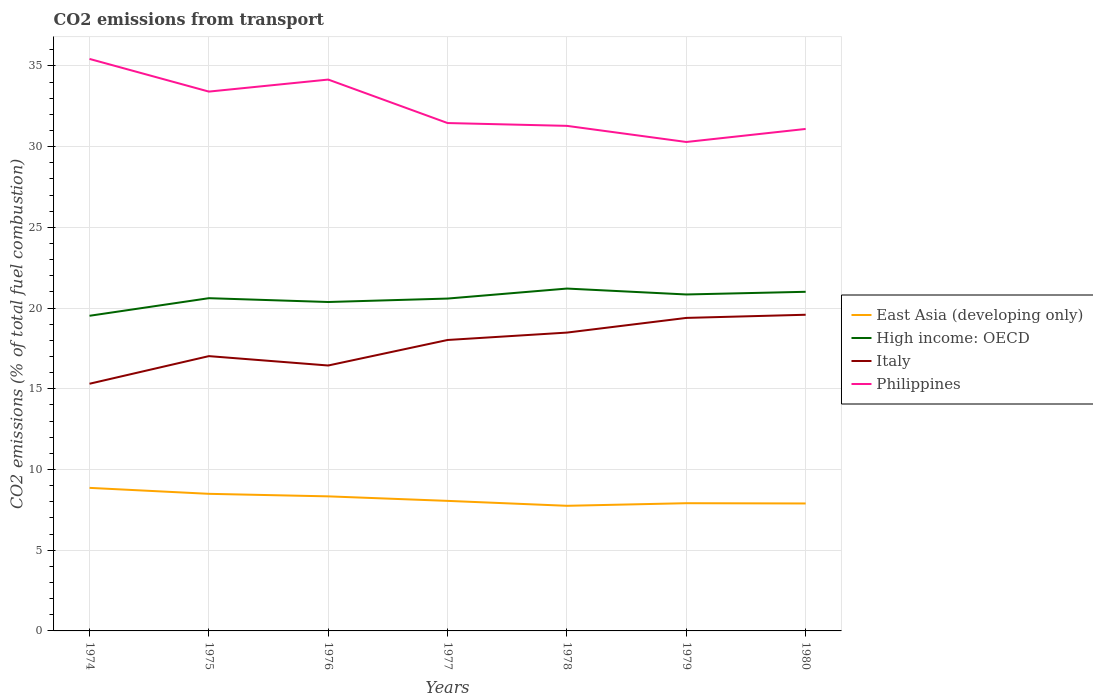How many different coloured lines are there?
Keep it short and to the point. 4. Is the number of lines equal to the number of legend labels?
Make the answer very short. Yes. Across all years, what is the maximum total CO2 emitted in East Asia (developing only)?
Provide a short and direct response. 7.75. In which year was the total CO2 emitted in Philippines maximum?
Offer a very short reply. 1979. What is the total total CO2 emitted in Italy in the graph?
Provide a short and direct response. -0.91. What is the difference between the highest and the second highest total CO2 emitted in High income: OECD?
Your response must be concise. 1.69. Is the total CO2 emitted in Philippines strictly greater than the total CO2 emitted in High income: OECD over the years?
Ensure brevity in your answer.  No. What is the difference between two consecutive major ticks on the Y-axis?
Keep it short and to the point. 5. Are the values on the major ticks of Y-axis written in scientific E-notation?
Make the answer very short. No. Does the graph contain any zero values?
Your answer should be very brief. No. Does the graph contain grids?
Provide a succinct answer. Yes. Where does the legend appear in the graph?
Offer a terse response. Center right. How many legend labels are there?
Keep it short and to the point. 4. How are the legend labels stacked?
Give a very brief answer. Vertical. What is the title of the graph?
Your answer should be very brief. CO2 emissions from transport. Does "Azerbaijan" appear as one of the legend labels in the graph?
Make the answer very short. No. What is the label or title of the Y-axis?
Give a very brief answer. CO2 emissions (% of total fuel combustion). What is the CO2 emissions (% of total fuel combustion) of East Asia (developing only) in 1974?
Offer a very short reply. 8.86. What is the CO2 emissions (% of total fuel combustion) of High income: OECD in 1974?
Offer a terse response. 19.52. What is the CO2 emissions (% of total fuel combustion) in Italy in 1974?
Offer a terse response. 15.31. What is the CO2 emissions (% of total fuel combustion) of Philippines in 1974?
Your answer should be compact. 35.44. What is the CO2 emissions (% of total fuel combustion) of East Asia (developing only) in 1975?
Your answer should be very brief. 8.49. What is the CO2 emissions (% of total fuel combustion) of High income: OECD in 1975?
Your response must be concise. 20.61. What is the CO2 emissions (% of total fuel combustion) in Italy in 1975?
Provide a succinct answer. 17.02. What is the CO2 emissions (% of total fuel combustion) in Philippines in 1975?
Offer a very short reply. 33.41. What is the CO2 emissions (% of total fuel combustion) of East Asia (developing only) in 1976?
Your answer should be compact. 8.34. What is the CO2 emissions (% of total fuel combustion) of High income: OECD in 1976?
Give a very brief answer. 20.38. What is the CO2 emissions (% of total fuel combustion) of Italy in 1976?
Offer a very short reply. 16.44. What is the CO2 emissions (% of total fuel combustion) of Philippines in 1976?
Make the answer very short. 34.16. What is the CO2 emissions (% of total fuel combustion) of East Asia (developing only) in 1977?
Offer a very short reply. 8.06. What is the CO2 emissions (% of total fuel combustion) in High income: OECD in 1977?
Provide a short and direct response. 20.59. What is the CO2 emissions (% of total fuel combustion) of Italy in 1977?
Provide a succinct answer. 18.03. What is the CO2 emissions (% of total fuel combustion) in Philippines in 1977?
Ensure brevity in your answer.  31.47. What is the CO2 emissions (% of total fuel combustion) of East Asia (developing only) in 1978?
Offer a terse response. 7.75. What is the CO2 emissions (% of total fuel combustion) in High income: OECD in 1978?
Provide a succinct answer. 21.21. What is the CO2 emissions (% of total fuel combustion) in Italy in 1978?
Make the answer very short. 18.48. What is the CO2 emissions (% of total fuel combustion) in Philippines in 1978?
Your answer should be very brief. 31.29. What is the CO2 emissions (% of total fuel combustion) in East Asia (developing only) in 1979?
Your response must be concise. 7.91. What is the CO2 emissions (% of total fuel combustion) in High income: OECD in 1979?
Your response must be concise. 20.85. What is the CO2 emissions (% of total fuel combustion) in Italy in 1979?
Offer a very short reply. 19.39. What is the CO2 emissions (% of total fuel combustion) in Philippines in 1979?
Your answer should be very brief. 30.29. What is the CO2 emissions (% of total fuel combustion) in East Asia (developing only) in 1980?
Make the answer very short. 7.9. What is the CO2 emissions (% of total fuel combustion) in High income: OECD in 1980?
Ensure brevity in your answer.  21.01. What is the CO2 emissions (% of total fuel combustion) of Italy in 1980?
Keep it short and to the point. 19.59. What is the CO2 emissions (% of total fuel combustion) of Philippines in 1980?
Provide a succinct answer. 31.1. Across all years, what is the maximum CO2 emissions (% of total fuel combustion) of East Asia (developing only)?
Make the answer very short. 8.86. Across all years, what is the maximum CO2 emissions (% of total fuel combustion) in High income: OECD?
Make the answer very short. 21.21. Across all years, what is the maximum CO2 emissions (% of total fuel combustion) of Italy?
Give a very brief answer. 19.59. Across all years, what is the maximum CO2 emissions (% of total fuel combustion) of Philippines?
Offer a terse response. 35.44. Across all years, what is the minimum CO2 emissions (% of total fuel combustion) of East Asia (developing only)?
Make the answer very short. 7.75. Across all years, what is the minimum CO2 emissions (% of total fuel combustion) of High income: OECD?
Your response must be concise. 19.52. Across all years, what is the minimum CO2 emissions (% of total fuel combustion) in Italy?
Give a very brief answer. 15.31. Across all years, what is the minimum CO2 emissions (% of total fuel combustion) of Philippines?
Ensure brevity in your answer.  30.29. What is the total CO2 emissions (% of total fuel combustion) in East Asia (developing only) in the graph?
Your response must be concise. 57.31. What is the total CO2 emissions (% of total fuel combustion) of High income: OECD in the graph?
Give a very brief answer. 144.17. What is the total CO2 emissions (% of total fuel combustion) in Italy in the graph?
Keep it short and to the point. 124.27. What is the total CO2 emissions (% of total fuel combustion) of Philippines in the graph?
Offer a terse response. 227.16. What is the difference between the CO2 emissions (% of total fuel combustion) of East Asia (developing only) in 1974 and that in 1975?
Make the answer very short. 0.37. What is the difference between the CO2 emissions (% of total fuel combustion) in High income: OECD in 1974 and that in 1975?
Make the answer very short. -1.09. What is the difference between the CO2 emissions (% of total fuel combustion) of Italy in 1974 and that in 1975?
Provide a short and direct response. -1.71. What is the difference between the CO2 emissions (% of total fuel combustion) in Philippines in 1974 and that in 1975?
Your response must be concise. 2.02. What is the difference between the CO2 emissions (% of total fuel combustion) of East Asia (developing only) in 1974 and that in 1976?
Provide a short and direct response. 0.53. What is the difference between the CO2 emissions (% of total fuel combustion) in High income: OECD in 1974 and that in 1976?
Your answer should be compact. -0.85. What is the difference between the CO2 emissions (% of total fuel combustion) in Italy in 1974 and that in 1976?
Offer a very short reply. -1.13. What is the difference between the CO2 emissions (% of total fuel combustion) in Philippines in 1974 and that in 1976?
Your response must be concise. 1.28. What is the difference between the CO2 emissions (% of total fuel combustion) in East Asia (developing only) in 1974 and that in 1977?
Offer a terse response. 0.81. What is the difference between the CO2 emissions (% of total fuel combustion) in High income: OECD in 1974 and that in 1977?
Offer a terse response. -1.07. What is the difference between the CO2 emissions (% of total fuel combustion) of Italy in 1974 and that in 1977?
Give a very brief answer. -2.71. What is the difference between the CO2 emissions (% of total fuel combustion) in Philippines in 1974 and that in 1977?
Keep it short and to the point. 3.97. What is the difference between the CO2 emissions (% of total fuel combustion) in East Asia (developing only) in 1974 and that in 1978?
Keep it short and to the point. 1.11. What is the difference between the CO2 emissions (% of total fuel combustion) in High income: OECD in 1974 and that in 1978?
Your response must be concise. -1.69. What is the difference between the CO2 emissions (% of total fuel combustion) of Italy in 1974 and that in 1978?
Your answer should be very brief. -3.17. What is the difference between the CO2 emissions (% of total fuel combustion) in Philippines in 1974 and that in 1978?
Provide a succinct answer. 4.15. What is the difference between the CO2 emissions (% of total fuel combustion) in East Asia (developing only) in 1974 and that in 1979?
Provide a short and direct response. 0.95. What is the difference between the CO2 emissions (% of total fuel combustion) in High income: OECD in 1974 and that in 1979?
Offer a terse response. -1.32. What is the difference between the CO2 emissions (% of total fuel combustion) in Italy in 1974 and that in 1979?
Give a very brief answer. -4.08. What is the difference between the CO2 emissions (% of total fuel combustion) in Philippines in 1974 and that in 1979?
Provide a short and direct response. 5.15. What is the difference between the CO2 emissions (% of total fuel combustion) of East Asia (developing only) in 1974 and that in 1980?
Make the answer very short. 0.97. What is the difference between the CO2 emissions (% of total fuel combustion) in High income: OECD in 1974 and that in 1980?
Offer a very short reply. -1.49. What is the difference between the CO2 emissions (% of total fuel combustion) of Italy in 1974 and that in 1980?
Your response must be concise. -4.27. What is the difference between the CO2 emissions (% of total fuel combustion) of Philippines in 1974 and that in 1980?
Make the answer very short. 4.34. What is the difference between the CO2 emissions (% of total fuel combustion) in East Asia (developing only) in 1975 and that in 1976?
Ensure brevity in your answer.  0.16. What is the difference between the CO2 emissions (% of total fuel combustion) in High income: OECD in 1975 and that in 1976?
Your answer should be very brief. 0.24. What is the difference between the CO2 emissions (% of total fuel combustion) in Italy in 1975 and that in 1976?
Give a very brief answer. 0.58. What is the difference between the CO2 emissions (% of total fuel combustion) of Philippines in 1975 and that in 1976?
Offer a terse response. -0.75. What is the difference between the CO2 emissions (% of total fuel combustion) in East Asia (developing only) in 1975 and that in 1977?
Your answer should be very brief. 0.44. What is the difference between the CO2 emissions (% of total fuel combustion) of High income: OECD in 1975 and that in 1977?
Ensure brevity in your answer.  0.02. What is the difference between the CO2 emissions (% of total fuel combustion) in Italy in 1975 and that in 1977?
Your answer should be very brief. -1. What is the difference between the CO2 emissions (% of total fuel combustion) of Philippines in 1975 and that in 1977?
Your response must be concise. 1.95. What is the difference between the CO2 emissions (% of total fuel combustion) in East Asia (developing only) in 1975 and that in 1978?
Your answer should be compact. 0.74. What is the difference between the CO2 emissions (% of total fuel combustion) of High income: OECD in 1975 and that in 1978?
Give a very brief answer. -0.6. What is the difference between the CO2 emissions (% of total fuel combustion) of Italy in 1975 and that in 1978?
Ensure brevity in your answer.  -1.46. What is the difference between the CO2 emissions (% of total fuel combustion) in Philippines in 1975 and that in 1978?
Offer a terse response. 2.12. What is the difference between the CO2 emissions (% of total fuel combustion) of East Asia (developing only) in 1975 and that in 1979?
Provide a succinct answer. 0.58. What is the difference between the CO2 emissions (% of total fuel combustion) in High income: OECD in 1975 and that in 1979?
Make the answer very short. -0.23. What is the difference between the CO2 emissions (% of total fuel combustion) of Italy in 1975 and that in 1979?
Your response must be concise. -2.37. What is the difference between the CO2 emissions (% of total fuel combustion) of Philippines in 1975 and that in 1979?
Your answer should be compact. 3.12. What is the difference between the CO2 emissions (% of total fuel combustion) in East Asia (developing only) in 1975 and that in 1980?
Your answer should be compact. 0.6. What is the difference between the CO2 emissions (% of total fuel combustion) in High income: OECD in 1975 and that in 1980?
Provide a succinct answer. -0.4. What is the difference between the CO2 emissions (% of total fuel combustion) of Italy in 1975 and that in 1980?
Your response must be concise. -2.56. What is the difference between the CO2 emissions (% of total fuel combustion) in Philippines in 1975 and that in 1980?
Your answer should be very brief. 2.31. What is the difference between the CO2 emissions (% of total fuel combustion) in East Asia (developing only) in 1976 and that in 1977?
Give a very brief answer. 0.28. What is the difference between the CO2 emissions (% of total fuel combustion) of High income: OECD in 1976 and that in 1977?
Provide a short and direct response. -0.21. What is the difference between the CO2 emissions (% of total fuel combustion) in Italy in 1976 and that in 1977?
Your response must be concise. -1.58. What is the difference between the CO2 emissions (% of total fuel combustion) in Philippines in 1976 and that in 1977?
Provide a succinct answer. 2.69. What is the difference between the CO2 emissions (% of total fuel combustion) in East Asia (developing only) in 1976 and that in 1978?
Keep it short and to the point. 0.58. What is the difference between the CO2 emissions (% of total fuel combustion) of High income: OECD in 1976 and that in 1978?
Your response must be concise. -0.83. What is the difference between the CO2 emissions (% of total fuel combustion) of Italy in 1976 and that in 1978?
Offer a very short reply. -2.04. What is the difference between the CO2 emissions (% of total fuel combustion) in Philippines in 1976 and that in 1978?
Give a very brief answer. 2.87. What is the difference between the CO2 emissions (% of total fuel combustion) in East Asia (developing only) in 1976 and that in 1979?
Your response must be concise. 0.42. What is the difference between the CO2 emissions (% of total fuel combustion) of High income: OECD in 1976 and that in 1979?
Ensure brevity in your answer.  -0.47. What is the difference between the CO2 emissions (% of total fuel combustion) of Italy in 1976 and that in 1979?
Provide a succinct answer. -2.95. What is the difference between the CO2 emissions (% of total fuel combustion) of Philippines in 1976 and that in 1979?
Make the answer very short. 3.87. What is the difference between the CO2 emissions (% of total fuel combustion) in East Asia (developing only) in 1976 and that in 1980?
Your answer should be very brief. 0.44. What is the difference between the CO2 emissions (% of total fuel combustion) in High income: OECD in 1976 and that in 1980?
Offer a very short reply. -0.63. What is the difference between the CO2 emissions (% of total fuel combustion) in Italy in 1976 and that in 1980?
Your answer should be very brief. -3.14. What is the difference between the CO2 emissions (% of total fuel combustion) in Philippines in 1976 and that in 1980?
Ensure brevity in your answer.  3.06. What is the difference between the CO2 emissions (% of total fuel combustion) in East Asia (developing only) in 1977 and that in 1978?
Offer a terse response. 0.31. What is the difference between the CO2 emissions (% of total fuel combustion) of High income: OECD in 1977 and that in 1978?
Your answer should be very brief. -0.62. What is the difference between the CO2 emissions (% of total fuel combustion) of Italy in 1977 and that in 1978?
Your answer should be very brief. -0.46. What is the difference between the CO2 emissions (% of total fuel combustion) in Philippines in 1977 and that in 1978?
Ensure brevity in your answer.  0.17. What is the difference between the CO2 emissions (% of total fuel combustion) in East Asia (developing only) in 1977 and that in 1979?
Ensure brevity in your answer.  0.14. What is the difference between the CO2 emissions (% of total fuel combustion) in High income: OECD in 1977 and that in 1979?
Make the answer very short. -0.25. What is the difference between the CO2 emissions (% of total fuel combustion) of Italy in 1977 and that in 1979?
Provide a short and direct response. -1.37. What is the difference between the CO2 emissions (% of total fuel combustion) in Philippines in 1977 and that in 1979?
Your response must be concise. 1.17. What is the difference between the CO2 emissions (% of total fuel combustion) in East Asia (developing only) in 1977 and that in 1980?
Ensure brevity in your answer.  0.16. What is the difference between the CO2 emissions (% of total fuel combustion) of High income: OECD in 1977 and that in 1980?
Offer a very short reply. -0.42. What is the difference between the CO2 emissions (% of total fuel combustion) in Italy in 1977 and that in 1980?
Your answer should be compact. -1.56. What is the difference between the CO2 emissions (% of total fuel combustion) in Philippines in 1977 and that in 1980?
Give a very brief answer. 0.37. What is the difference between the CO2 emissions (% of total fuel combustion) in East Asia (developing only) in 1978 and that in 1979?
Provide a short and direct response. -0.16. What is the difference between the CO2 emissions (% of total fuel combustion) of High income: OECD in 1978 and that in 1979?
Offer a very short reply. 0.37. What is the difference between the CO2 emissions (% of total fuel combustion) of Italy in 1978 and that in 1979?
Offer a terse response. -0.91. What is the difference between the CO2 emissions (% of total fuel combustion) of East Asia (developing only) in 1978 and that in 1980?
Your answer should be very brief. -0.14. What is the difference between the CO2 emissions (% of total fuel combustion) of High income: OECD in 1978 and that in 1980?
Offer a terse response. 0.2. What is the difference between the CO2 emissions (% of total fuel combustion) of Italy in 1978 and that in 1980?
Your response must be concise. -1.11. What is the difference between the CO2 emissions (% of total fuel combustion) in Philippines in 1978 and that in 1980?
Your answer should be compact. 0.19. What is the difference between the CO2 emissions (% of total fuel combustion) in East Asia (developing only) in 1979 and that in 1980?
Your response must be concise. 0.02. What is the difference between the CO2 emissions (% of total fuel combustion) in High income: OECD in 1979 and that in 1980?
Offer a very short reply. -0.17. What is the difference between the CO2 emissions (% of total fuel combustion) in Italy in 1979 and that in 1980?
Offer a very short reply. -0.2. What is the difference between the CO2 emissions (% of total fuel combustion) in Philippines in 1979 and that in 1980?
Make the answer very short. -0.81. What is the difference between the CO2 emissions (% of total fuel combustion) of East Asia (developing only) in 1974 and the CO2 emissions (% of total fuel combustion) of High income: OECD in 1975?
Your answer should be very brief. -11.75. What is the difference between the CO2 emissions (% of total fuel combustion) of East Asia (developing only) in 1974 and the CO2 emissions (% of total fuel combustion) of Italy in 1975?
Ensure brevity in your answer.  -8.16. What is the difference between the CO2 emissions (% of total fuel combustion) of East Asia (developing only) in 1974 and the CO2 emissions (% of total fuel combustion) of Philippines in 1975?
Give a very brief answer. -24.55. What is the difference between the CO2 emissions (% of total fuel combustion) of High income: OECD in 1974 and the CO2 emissions (% of total fuel combustion) of Italy in 1975?
Keep it short and to the point. 2.5. What is the difference between the CO2 emissions (% of total fuel combustion) in High income: OECD in 1974 and the CO2 emissions (% of total fuel combustion) in Philippines in 1975?
Give a very brief answer. -13.89. What is the difference between the CO2 emissions (% of total fuel combustion) of Italy in 1974 and the CO2 emissions (% of total fuel combustion) of Philippines in 1975?
Keep it short and to the point. -18.1. What is the difference between the CO2 emissions (% of total fuel combustion) of East Asia (developing only) in 1974 and the CO2 emissions (% of total fuel combustion) of High income: OECD in 1976?
Make the answer very short. -11.52. What is the difference between the CO2 emissions (% of total fuel combustion) of East Asia (developing only) in 1974 and the CO2 emissions (% of total fuel combustion) of Italy in 1976?
Your answer should be compact. -7.58. What is the difference between the CO2 emissions (% of total fuel combustion) of East Asia (developing only) in 1974 and the CO2 emissions (% of total fuel combustion) of Philippines in 1976?
Your answer should be very brief. -25.3. What is the difference between the CO2 emissions (% of total fuel combustion) of High income: OECD in 1974 and the CO2 emissions (% of total fuel combustion) of Italy in 1976?
Offer a very short reply. 3.08. What is the difference between the CO2 emissions (% of total fuel combustion) in High income: OECD in 1974 and the CO2 emissions (% of total fuel combustion) in Philippines in 1976?
Provide a short and direct response. -14.63. What is the difference between the CO2 emissions (% of total fuel combustion) in Italy in 1974 and the CO2 emissions (% of total fuel combustion) in Philippines in 1976?
Give a very brief answer. -18.84. What is the difference between the CO2 emissions (% of total fuel combustion) of East Asia (developing only) in 1974 and the CO2 emissions (% of total fuel combustion) of High income: OECD in 1977?
Ensure brevity in your answer.  -11.73. What is the difference between the CO2 emissions (% of total fuel combustion) in East Asia (developing only) in 1974 and the CO2 emissions (% of total fuel combustion) in Italy in 1977?
Give a very brief answer. -9.16. What is the difference between the CO2 emissions (% of total fuel combustion) of East Asia (developing only) in 1974 and the CO2 emissions (% of total fuel combustion) of Philippines in 1977?
Provide a short and direct response. -22.6. What is the difference between the CO2 emissions (% of total fuel combustion) in High income: OECD in 1974 and the CO2 emissions (% of total fuel combustion) in Italy in 1977?
Keep it short and to the point. 1.5. What is the difference between the CO2 emissions (% of total fuel combustion) of High income: OECD in 1974 and the CO2 emissions (% of total fuel combustion) of Philippines in 1977?
Your response must be concise. -11.94. What is the difference between the CO2 emissions (% of total fuel combustion) in Italy in 1974 and the CO2 emissions (% of total fuel combustion) in Philippines in 1977?
Offer a terse response. -16.15. What is the difference between the CO2 emissions (% of total fuel combustion) of East Asia (developing only) in 1974 and the CO2 emissions (% of total fuel combustion) of High income: OECD in 1978?
Make the answer very short. -12.35. What is the difference between the CO2 emissions (% of total fuel combustion) of East Asia (developing only) in 1974 and the CO2 emissions (% of total fuel combustion) of Italy in 1978?
Give a very brief answer. -9.62. What is the difference between the CO2 emissions (% of total fuel combustion) in East Asia (developing only) in 1974 and the CO2 emissions (% of total fuel combustion) in Philippines in 1978?
Make the answer very short. -22.43. What is the difference between the CO2 emissions (% of total fuel combustion) in High income: OECD in 1974 and the CO2 emissions (% of total fuel combustion) in Italy in 1978?
Provide a short and direct response. 1.04. What is the difference between the CO2 emissions (% of total fuel combustion) in High income: OECD in 1974 and the CO2 emissions (% of total fuel combustion) in Philippines in 1978?
Ensure brevity in your answer.  -11.77. What is the difference between the CO2 emissions (% of total fuel combustion) in Italy in 1974 and the CO2 emissions (% of total fuel combustion) in Philippines in 1978?
Your answer should be very brief. -15.98. What is the difference between the CO2 emissions (% of total fuel combustion) of East Asia (developing only) in 1974 and the CO2 emissions (% of total fuel combustion) of High income: OECD in 1979?
Provide a short and direct response. -11.98. What is the difference between the CO2 emissions (% of total fuel combustion) in East Asia (developing only) in 1974 and the CO2 emissions (% of total fuel combustion) in Italy in 1979?
Offer a terse response. -10.53. What is the difference between the CO2 emissions (% of total fuel combustion) in East Asia (developing only) in 1974 and the CO2 emissions (% of total fuel combustion) in Philippines in 1979?
Keep it short and to the point. -21.43. What is the difference between the CO2 emissions (% of total fuel combustion) in High income: OECD in 1974 and the CO2 emissions (% of total fuel combustion) in Italy in 1979?
Keep it short and to the point. 0.13. What is the difference between the CO2 emissions (% of total fuel combustion) of High income: OECD in 1974 and the CO2 emissions (% of total fuel combustion) of Philippines in 1979?
Make the answer very short. -10.77. What is the difference between the CO2 emissions (% of total fuel combustion) in Italy in 1974 and the CO2 emissions (% of total fuel combustion) in Philippines in 1979?
Give a very brief answer. -14.98. What is the difference between the CO2 emissions (% of total fuel combustion) in East Asia (developing only) in 1974 and the CO2 emissions (% of total fuel combustion) in High income: OECD in 1980?
Provide a short and direct response. -12.15. What is the difference between the CO2 emissions (% of total fuel combustion) of East Asia (developing only) in 1974 and the CO2 emissions (% of total fuel combustion) of Italy in 1980?
Your response must be concise. -10.73. What is the difference between the CO2 emissions (% of total fuel combustion) in East Asia (developing only) in 1974 and the CO2 emissions (% of total fuel combustion) in Philippines in 1980?
Make the answer very short. -22.24. What is the difference between the CO2 emissions (% of total fuel combustion) in High income: OECD in 1974 and the CO2 emissions (% of total fuel combustion) in Italy in 1980?
Provide a short and direct response. -0.06. What is the difference between the CO2 emissions (% of total fuel combustion) of High income: OECD in 1974 and the CO2 emissions (% of total fuel combustion) of Philippines in 1980?
Offer a very short reply. -11.58. What is the difference between the CO2 emissions (% of total fuel combustion) of Italy in 1974 and the CO2 emissions (% of total fuel combustion) of Philippines in 1980?
Make the answer very short. -15.79. What is the difference between the CO2 emissions (% of total fuel combustion) of East Asia (developing only) in 1975 and the CO2 emissions (% of total fuel combustion) of High income: OECD in 1976?
Offer a very short reply. -11.88. What is the difference between the CO2 emissions (% of total fuel combustion) of East Asia (developing only) in 1975 and the CO2 emissions (% of total fuel combustion) of Italy in 1976?
Your response must be concise. -7.95. What is the difference between the CO2 emissions (% of total fuel combustion) of East Asia (developing only) in 1975 and the CO2 emissions (% of total fuel combustion) of Philippines in 1976?
Give a very brief answer. -25.67. What is the difference between the CO2 emissions (% of total fuel combustion) in High income: OECD in 1975 and the CO2 emissions (% of total fuel combustion) in Italy in 1976?
Keep it short and to the point. 4.17. What is the difference between the CO2 emissions (% of total fuel combustion) in High income: OECD in 1975 and the CO2 emissions (% of total fuel combustion) in Philippines in 1976?
Give a very brief answer. -13.54. What is the difference between the CO2 emissions (% of total fuel combustion) in Italy in 1975 and the CO2 emissions (% of total fuel combustion) in Philippines in 1976?
Provide a short and direct response. -17.13. What is the difference between the CO2 emissions (% of total fuel combustion) in East Asia (developing only) in 1975 and the CO2 emissions (% of total fuel combustion) in High income: OECD in 1977?
Offer a terse response. -12.1. What is the difference between the CO2 emissions (% of total fuel combustion) of East Asia (developing only) in 1975 and the CO2 emissions (% of total fuel combustion) of Italy in 1977?
Provide a succinct answer. -9.53. What is the difference between the CO2 emissions (% of total fuel combustion) in East Asia (developing only) in 1975 and the CO2 emissions (% of total fuel combustion) in Philippines in 1977?
Your response must be concise. -22.97. What is the difference between the CO2 emissions (% of total fuel combustion) in High income: OECD in 1975 and the CO2 emissions (% of total fuel combustion) in Italy in 1977?
Provide a succinct answer. 2.59. What is the difference between the CO2 emissions (% of total fuel combustion) of High income: OECD in 1975 and the CO2 emissions (% of total fuel combustion) of Philippines in 1977?
Provide a succinct answer. -10.85. What is the difference between the CO2 emissions (% of total fuel combustion) in Italy in 1975 and the CO2 emissions (% of total fuel combustion) in Philippines in 1977?
Offer a terse response. -14.44. What is the difference between the CO2 emissions (% of total fuel combustion) in East Asia (developing only) in 1975 and the CO2 emissions (% of total fuel combustion) in High income: OECD in 1978?
Keep it short and to the point. -12.72. What is the difference between the CO2 emissions (% of total fuel combustion) of East Asia (developing only) in 1975 and the CO2 emissions (% of total fuel combustion) of Italy in 1978?
Offer a terse response. -9.99. What is the difference between the CO2 emissions (% of total fuel combustion) of East Asia (developing only) in 1975 and the CO2 emissions (% of total fuel combustion) of Philippines in 1978?
Provide a succinct answer. -22.8. What is the difference between the CO2 emissions (% of total fuel combustion) in High income: OECD in 1975 and the CO2 emissions (% of total fuel combustion) in Italy in 1978?
Provide a succinct answer. 2.13. What is the difference between the CO2 emissions (% of total fuel combustion) in High income: OECD in 1975 and the CO2 emissions (% of total fuel combustion) in Philippines in 1978?
Ensure brevity in your answer.  -10.68. What is the difference between the CO2 emissions (% of total fuel combustion) in Italy in 1975 and the CO2 emissions (% of total fuel combustion) in Philippines in 1978?
Keep it short and to the point. -14.27. What is the difference between the CO2 emissions (% of total fuel combustion) of East Asia (developing only) in 1975 and the CO2 emissions (% of total fuel combustion) of High income: OECD in 1979?
Give a very brief answer. -12.35. What is the difference between the CO2 emissions (% of total fuel combustion) of East Asia (developing only) in 1975 and the CO2 emissions (% of total fuel combustion) of Italy in 1979?
Your response must be concise. -10.9. What is the difference between the CO2 emissions (% of total fuel combustion) of East Asia (developing only) in 1975 and the CO2 emissions (% of total fuel combustion) of Philippines in 1979?
Give a very brief answer. -21.8. What is the difference between the CO2 emissions (% of total fuel combustion) in High income: OECD in 1975 and the CO2 emissions (% of total fuel combustion) in Italy in 1979?
Provide a succinct answer. 1.22. What is the difference between the CO2 emissions (% of total fuel combustion) in High income: OECD in 1975 and the CO2 emissions (% of total fuel combustion) in Philippines in 1979?
Keep it short and to the point. -9.68. What is the difference between the CO2 emissions (% of total fuel combustion) in Italy in 1975 and the CO2 emissions (% of total fuel combustion) in Philippines in 1979?
Provide a succinct answer. -13.27. What is the difference between the CO2 emissions (% of total fuel combustion) in East Asia (developing only) in 1975 and the CO2 emissions (% of total fuel combustion) in High income: OECD in 1980?
Your response must be concise. -12.52. What is the difference between the CO2 emissions (% of total fuel combustion) in East Asia (developing only) in 1975 and the CO2 emissions (% of total fuel combustion) in Italy in 1980?
Offer a very short reply. -11.1. What is the difference between the CO2 emissions (% of total fuel combustion) in East Asia (developing only) in 1975 and the CO2 emissions (% of total fuel combustion) in Philippines in 1980?
Your answer should be compact. -22.61. What is the difference between the CO2 emissions (% of total fuel combustion) of High income: OECD in 1975 and the CO2 emissions (% of total fuel combustion) of Italy in 1980?
Provide a short and direct response. 1.03. What is the difference between the CO2 emissions (% of total fuel combustion) in High income: OECD in 1975 and the CO2 emissions (% of total fuel combustion) in Philippines in 1980?
Your answer should be compact. -10.49. What is the difference between the CO2 emissions (% of total fuel combustion) of Italy in 1975 and the CO2 emissions (% of total fuel combustion) of Philippines in 1980?
Your answer should be very brief. -14.07. What is the difference between the CO2 emissions (% of total fuel combustion) of East Asia (developing only) in 1976 and the CO2 emissions (% of total fuel combustion) of High income: OECD in 1977?
Ensure brevity in your answer.  -12.25. What is the difference between the CO2 emissions (% of total fuel combustion) in East Asia (developing only) in 1976 and the CO2 emissions (% of total fuel combustion) in Italy in 1977?
Provide a succinct answer. -9.69. What is the difference between the CO2 emissions (% of total fuel combustion) in East Asia (developing only) in 1976 and the CO2 emissions (% of total fuel combustion) in Philippines in 1977?
Ensure brevity in your answer.  -23.13. What is the difference between the CO2 emissions (% of total fuel combustion) of High income: OECD in 1976 and the CO2 emissions (% of total fuel combustion) of Italy in 1977?
Provide a short and direct response. 2.35. What is the difference between the CO2 emissions (% of total fuel combustion) in High income: OECD in 1976 and the CO2 emissions (% of total fuel combustion) in Philippines in 1977?
Offer a terse response. -11.09. What is the difference between the CO2 emissions (% of total fuel combustion) in Italy in 1976 and the CO2 emissions (% of total fuel combustion) in Philippines in 1977?
Give a very brief answer. -15.02. What is the difference between the CO2 emissions (% of total fuel combustion) in East Asia (developing only) in 1976 and the CO2 emissions (% of total fuel combustion) in High income: OECD in 1978?
Ensure brevity in your answer.  -12.87. What is the difference between the CO2 emissions (% of total fuel combustion) of East Asia (developing only) in 1976 and the CO2 emissions (% of total fuel combustion) of Italy in 1978?
Keep it short and to the point. -10.15. What is the difference between the CO2 emissions (% of total fuel combustion) of East Asia (developing only) in 1976 and the CO2 emissions (% of total fuel combustion) of Philippines in 1978?
Give a very brief answer. -22.95. What is the difference between the CO2 emissions (% of total fuel combustion) in High income: OECD in 1976 and the CO2 emissions (% of total fuel combustion) in Italy in 1978?
Make the answer very short. 1.9. What is the difference between the CO2 emissions (% of total fuel combustion) in High income: OECD in 1976 and the CO2 emissions (% of total fuel combustion) in Philippines in 1978?
Your answer should be compact. -10.91. What is the difference between the CO2 emissions (% of total fuel combustion) in Italy in 1976 and the CO2 emissions (% of total fuel combustion) in Philippines in 1978?
Ensure brevity in your answer.  -14.85. What is the difference between the CO2 emissions (% of total fuel combustion) in East Asia (developing only) in 1976 and the CO2 emissions (% of total fuel combustion) in High income: OECD in 1979?
Keep it short and to the point. -12.51. What is the difference between the CO2 emissions (% of total fuel combustion) of East Asia (developing only) in 1976 and the CO2 emissions (% of total fuel combustion) of Italy in 1979?
Give a very brief answer. -11.06. What is the difference between the CO2 emissions (% of total fuel combustion) of East Asia (developing only) in 1976 and the CO2 emissions (% of total fuel combustion) of Philippines in 1979?
Provide a succinct answer. -21.96. What is the difference between the CO2 emissions (% of total fuel combustion) of High income: OECD in 1976 and the CO2 emissions (% of total fuel combustion) of Italy in 1979?
Offer a very short reply. 0.99. What is the difference between the CO2 emissions (% of total fuel combustion) in High income: OECD in 1976 and the CO2 emissions (% of total fuel combustion) in Philippines in 1979?
Your response must be concise. -9.91. What is the difference between the CO2 emissions (% of total fuel combustion) of Italy in 1976 and the CO2 emissions (% of total fuel combustion) of Philippines in 1979?
Your answer should be compact. -13.85. What is the difference between the CO2 emissions (% of total fuel combustion) of East Asia (developing only) in 1976 and the CO2 emissions (% of total fuel combustion) of High income: OECD in 1980?
Make the answer very short. -12.67. What is the difference between the CO2 emissions (% of total fuel combustion) in East Asia (developing only) in 1976 and the CO2 emissions (% of total fuel combustion) in Italy in 1980?
Provide a short and direct response. -11.25. What is the difference between the CO2 emissions (% of total fuel combustion) of East Asia (developing only) in 1976 and the CO2 emissions (% of total fuel combustion) of Philippines in 1980?
Your answer should be compact. -22.76. What is the difference between the CO2 emissions (% of total fuel combustion) of High income: OECD in 1976 and the CO2 emissions (% of total fuel combustion) of Italy in 1980?
Provide a short and direct response. 0.79. What is the difference between the CO2 emissions (% of total fuel combustion) in High income: OECD in 1976 and the CO2 emissions (% of total fuel combustion) in Philippines in 1980?
Keep it short and to the point. -10.72. What is the difference between the CO2 emissions (% of total fuel combustion) of Italy in 1976 and the CO2 emissions (% of total fuel combustion) of Philippines in 1980?
Give a very brief answer. -14.66. What is the difference between the CO2 emissions (% of total fuel combustion) in East Asia (developing only) in 1977 and the CO2 emissions (% of total fuel combustion) in High income: OECD in 1978?
Provide a short and direct response. -13.15. What is the difference between the CO2 emissions (% of total fuel combustion) in East Asia (developing only) in 1977 and the CO2 emissions (% of total fuel combustion) in Italy in 1978?
Your answer should be compact. -10.43. What is the difference between the CO2 emissions (% of total fuel combustion) in East Asia (developing only) in 1977 and the CO2 emissions (% of total fuel combustion) in Philippines in 1978?
Make the answer very short. -23.23. What is the difference between the CO2 emissions (% of total fuel combustion) of High income: OECD in 1977 and the CO2 emissions (% of total fuel combustion) of Italy in 1978?
Provide a succinct answer. 2.11. What is the difference between the CO2 emissions (% of total fuel combustion) of High income: OECD in 1977 and the CO2 emissions (% of total fuel combustion) of Philippines in 1978?
Keep it short and to the point. -10.7. What is the difference between the CO2 emissions (% of total fuel combustion) in Italy in 1977 and the CO2 emissions (% of total fuel combustion) in Philippines in 1978?
Provide a short and direct response. -13.27. What is the difference between the CO2 emissions (% of total fuel combustion) of East Asia (developing only) in 1977 and the CO2 emissions (% of total fuel combustion) of High income: OECD in 1979?
Offer a very short reply. -12.79. What is the difference between the CO2 emissions (% of total fuel combustion) of East Asia (developing only) in 1977 and the CO2 emissions (% of total fuel combustion) of Italy in 1979?
Your answer should be very brief. -11.34. What is the difference between the CO2 emissions (% of total fuel combustion) in East Asia (developing only) in 1977 and the CO2 emissions (% of total fuel combustion) in Philippines in 1979?
Provide a succinct answer. -22.23. What is the difference between the CO2 emissions (% of total fuel combustion) in High income: OECD in 1977 and the CO2 emissions (% of total fuel combustion) in Italy in 1979?
Ensure brevity in your answer.  1.2. What is the difference between the CO2 emissions (% of total fuel combustion) in High income: OECD in 1977 and the CO2 emissions (% of total fuel combustion) in Philippines in 1979?
Make the answer very short. -9.7. What is the difference between the CO2 emissions (% of total fuel combustion) in Italy in 1977 and the CO2 emissions (% of total fuel combustion) in Philippines in 1979?
Keep it short and to the point. -12.27. What is the difference between the CO2 emissions (% of total fuel combustion) of East Asia (developing only) in 1977 and the CO2 emissions (% of total fuel combustion) of High income: OECD in 1980?
Give a very brief answer. -12.95. What is the difference between the CO2 emissions (% of total fuel combustion) in East Asia (developing only) in 1977 and the CO2 emissions (% of total fuel combustion) in Italy in 1980?
Give a very brief answer. -11.53. What is the difference between the CO2 emissions (% of total fuel combustion) in East Asia (developing only) in 1977 and the CO2 emissions (% of total fuel combustion) in Philippines in 1980?
Provide a succinct answer. -23.04. What is the difference between the CO2 emissions (% of total fuel combustion) in High income: OECD in 1977 and the CO2 emissions (% of total fuel combustion) in Philippines in 1980?
Make the answer very short. -10.51. What is the difference between the CO2 emissions (% of total fuel combustion) of Italy in 1977 and the CO2 emissions (% of total fuel combustion) of Philippines in 1980?
Provide a short and direct response. -13.07. What is the difference between the CO2 emissions (% of total fuel combustion) in East Asia (developing only) in 1978 and the CO2 emissions (% of total fuel combustion) in High income: OECD in 1979?
Make the answer very short. -13.09. What is the difference between the CO2 emissions (% of total fuel combustion) of East Asia (developing only) in 1978 and the CO2 emissions (% of total fuel combustion) of Italy in 1979?
Offer a terse response. -11.64. What is the difference between the CO2 emissions (% of total fuel combustion) in East Asia (developing only) in 1978 and the CO2 emissions (% of total fuel combustion) in Philippines in 1979?
Provide a succinct answer. -22.54. What is the difference between the CO2 emissions (% of total fuel combustion) in High income: OECD in 1978 and the CO2 emissions (% of total fuel combustion) in Italy in 1979?
Provide a succinct answer. 1.82. What is the difference between the CO2 emissions (% of total fuel combustion) of High income: OECD in 1978 and the CO2 emissions (% of total fuel combustion) of Philippines in 1979?
Ensure brevity in your answer.  -9.08. What is the difference between the CO2 emissions (% of total fuel combustion) of Italy in 1978 and the CO2 emissions (% of total fuel combustion) of Philippines in 1979?
Provide a succinct answer. -11.81. What is the difference between the CO2 emissions (% of total fuel combustion) in East Asia (developing only) in 1978 and the CO2 emissions (% of total fuel combustion) in High income: OECD in 1980?
Your response must be concise. -13.26. What is the difference between the CO2 emissions (% of total fuel combustion) in East Asia (developing only) in 1978 and the CO2 emissions (% of total fuel combustion) in Italy in 1980?
Offer a very short reply. -11.84. What is the difference between the CO2 emissions (% of total fuel combustion) in East Asia (developing only) in 1978 and the CO2 emissions (% of total fuel combustion) in Philippines in 1980?
Offer a very short reply. -23.35. What is the difference between the CO2 emissions (% of total fuel combustion) in High income: OECD in 1978 and the CO2 emissions (% of total fuel combustion) in Italy in 1980?
Give a very brief answer. 1.62. What is the difference between the CO2 emissions (% of total fuel combustion) in High income: OECD in 1978 and the CO2 emissions (% of total fuel combustion) in Philippines in 1980?
Your answer should be very brief. -9.89. What is the difference between the CO2 emissions (% of total fuel combustion) in Italy in 1978 and the CO2 emissions (% of total fuel combustion) in Philippines in 1980?
Provide a succinct answer. -12.62. What is the difference between the CO2 emissions (% of total fuel combustion) in East Asia (developing only) in 1979 and the CO2 emissions (% of total fuel combustion) in High income: OECD in 1980?
Make the answer very short. -13.1. What is the difference between the CO2 emissions (% of total fuel combustion) of East Asia (developing only) in 1979 and the CO2 emissions (% of total fuel combustion) of Italy in 1980?
Offer a very short reply. -11.68. What is the difference between the CO2 emissions (% of total fuel combustion) of East Asia (developing only) in 1979 and the CO2 emissions (% of total fuel combustion) of Philippines in 1980?
Your response must be concise. -23.19. What is the difference between the CO2 emissions (% of total fuel combustion) of High income: OECD in 1979 and the CO2 emissions (% of total fuel combustion) of Italy in 1980?
Provide a succinct answer. 1.26. What is the difference between the CO2 emissions (% of total fuel combustion) of High income: OECD in 1979 and the CO2 emissions (% of total fuel combustion) of Philippines in 1980?
Ensure brevity in your answer.  -10.25. What is the difference between the CO2 emissions (% of total fuel combustion) of Italy in 1979 and the CO2 emissions (% of total fuel combustion) of Philippines in 1980?
Your response must be concise. -11.71. What is the average CO2 emissions (% of total fuel combustion) in East Asia (developing only) per year?
Your answer should be very brief. 8.19. What is the average CO2 emissions (% of total fuel combustion) of High income: OECD per year?
Your answer should be very brief. 20.6. What is the average CO2 emissions (% of total fuel combustion) in Italy per year?
Provide a short and direct response. 17.75. What is the average CO2 emissions (% of total fuel combustion) of Philippines per year?
Make the answer very short. 32.45. In the year 1974, what is the difference between the CO2 emissions (% of total fuel combustion) of East Asia (developing only) and CO2 emissions (% of total fuel combustion) of High income: OECD?
Make the answer very short. -10.66. In the year 1974, what is the difference between the CO2 emissions (% of total fuel combustion) in East Asia (developing only) and CO2 emissions (% of total fuel combustion) in Italy?
Keep it short and to the point. -6.45. In the year 1974, what is the difference between the CO2 emissions (% of total fuel combustion) in East Asia (developing only) and CO2 emissions (% of total fuel combustion) in Philippines?
Your answer should be very brief. -26.58. In the year 1974, what is the difference between the CO2 emissions (% of total fuel combustion) of High income: OECD and CO2 emissions (% of total fuel combustion) of Italy?
Your response must be concise. 4.21. In the year 1974, what is the difference between the CO2 emissions (% of total fuel combustion) of High income: OECD and CO2 emissions (% of total fuel combustion) of Philippines?
Give a very brief answer. -15.91. In the year 1974, what is the difference between the CO2 emissions (% of total fuel combustion) in Italy and CO2 emissions (% of total fuel combustion) in Philippines?
Your answer should be compact. -20.12. In the year 1975, what is the difference between the CO2 emissions (% of total fuel combustion) in East Asia (developing only) and CO2 emissions (% of total fuel combustion) in High income: OECD?
Provide a succinct answer. -12.12. In the year 1975, what is the difference between the CO2 emissions (% of total fuel combustion) of East Asia (developing only) and CO2 emissions (% of total fuel combustion) of Italy?
Make the answer very short. -8.53. In the year 1975, what is the difference between the CO2 emissions (% of total fuel combustion) in East Asia (developing only) and CO2 emissions (% of total fuel combustion) in Philippines?
Provide a short and direct response. -24.92. In the year 1975, what is the difference between the CO2 emissions (% of total fuel combustion) in High income: OECD and CO2 emissions (% of total fuel combustion) in Italy?
Your answer should be compact. 3.59. In the year 1975, what is the difference between the CO2 emissions (% of total fuel combustion) of High income: OECD and CO2 emissions (% of total fuel combustion) of Philippines?
Ensure brevity in your answer.  -12.8. In the year 1975, what is the difference between the CO2 emissions (% of total fuel combustion) in Italy and CO2 emissions (% of total fuel combustion) in Philippines?
Provide a short and direct response. -16.39. In the year 1976, what is the difference between the CO2 emissions (% of total fuel combustion) in East Asia (developing only) and CO2 emissions (% of total fuel combustion) in High income: OECD?
Keep it short and to the point. -12.04. In the year 1976, what is the difference between the CO2 emissions (% of total fuel combustion) of East Asia (developing only) and CO2 emissions (% of total fuel combustion) of Italy?
Offer a very short reply. -8.11. In the year 1976, what is the difference between the CO2 emissions (% of total fuel combustion) of East Asia (developing only) and CO2 emissions (% of total fuel combustion) of Philippines?
Provide a short and direct response. -25.82. In the year 1976, what is the difference between the CO2 emissions (% of total fuel combustion) of High income: OECD and CO2 emissions (% of total fuel combustion) of Italy?
Provide a short and direct response. 3.93. In the year 1976, what is the difference between the CO2 emissions (% of total fuel combustion) in High income: OECD and CO2 emissions (% of total fuel combustion) in Philippines?
Offer a very short reply. -13.78. In the year 1976, what is the difference between the CO2 emissions (% of total fuel combustion) of Italy and CO2 emissions (% of total fuel combustion) of Philippines?
Your answer should be very brief. -17.71. In the year 1977, what is the difference between the CO2 emissions (% of total fuel combustion) of East Asia (developing only) and CO2 emissions (% of total fuel combustion) of High income: OECD?
Provide a succinct answer. -12.53. In the year 1977, what is the difference between the CO2 emissions (% of total fuel combustion) in East Asia (developing only) and CO2 emissions (% of total fuel combustion) in Italy?
Your answer should be compact. -9.97. In the year 1977, what is the difference between the CO2 emissions (% of total fuel combustion) in East Asia (developing only) and CO2 emissions (% of total fuel combustion) in Philippines?
Your answer should be very brief. -23.41. In the year 1977, what is the difference between the CO2 emissions (% of total fuel combustion) of High income: OECD and CO2 emissions (% of total fuel combustion) of Italy?
Your response must be concise. 2.57. In the year 1977, what is the difference between the CO2 emissions (% of total fuel combustion) of High income: OECD and CO2 emissions (% of total fuel combustion) of Philippines?
Provide a succinct answer. -10.87. In the year 1977, what is the difference between the CO2 emissions (% of total fuel combustion) of Italy and CO2 emissions (% of total fuel combustion) of Philippines?
Your response must be concise. -13.44. In the year 1978, what is the difference between the CO2 emissions (% of total fuel combustion) in East Asia (developing only) and CO2 emissions (% of total fuel combustion) in High income: OECD?
Provide a short and direct response. -13.46. In the year 1978, what is the difference between the CO2 emissions (% of total fuel combustion) of East Asia (developing only) and CO2 emissions (% of total fuel combustion) of Italy?
Provide a succinct answer. -10.73. In the year 1978, what is the difference between the CO2 emissions (% of total fuel combustion) of East Asia (developing only) and CO2 emissions (% of total fuel combustion) of Philippines?
Your answer should be very brief. -23.54. In the year 1978, what is the difference between the CO2 emissions (% of total fuel combustion) of High income: OECD and CO2 emissions (% of total fuel combustion) of Italy?
Your response must be concise. 2.73. In the year 1978, what is the difference between the CO2 emissions (% of total fuel combustion) in High income: OECD and CO2 emissions (% of total fuel combustion) in Philippines?
Your answer should be compact. -10.08. In the year 1978, what is the difference between the CO2 emissions (% of total fuel combustion) of Italy and CO2 emissions (% of total fuel combustion) of Philippines?
Your answer should be compact. -12.81. In the year 1979, what is the difference between the CO2 emissions (% of total fuel combustion) in East Asia (developing only) and CO2 emissions (% of total fuel combustion) in High income: OECD?
Provide a short and direct response. -12.93. In the year 1979, what is the difference between the CO2 emissions (% of total fuel combustion) in East Asia (developing only) and CO2 emissions (% of total fuel combustion) in Italy?
Ensure brevity in your answer.  -11.48. In the year 1979, what is the difference between the CO2 emissions (% of total fuel combustion) in East Asia (developing only) and CO2 emissions (% of total fuel combustion) in Philippines?
Keep it short and to the point. -22.38. In the year 1979, what is the difference between the CO2 emissions (% of total fuel combustion) in High income: OECD and CO2 emissions (% of total fuel combustion) in Italy?
Your response must be concise. 1.45. In the year 1979, what is the difference between the CO2 emissions (% of total fuel combustion) of High income: OECD and CO2 emissions (% of total fuel combustion) of Philippines?
Keep it short and to the point. -9.45. In the year 1979, what is the difference between the CO2 emissions (% of total fuel combustion) in Italy and CO2 emissions (% of total fuel combustion) in Philippines?
Keep it short and to the point. -10.9. In the year 1980, what is the difference between the CO2 emissions (% of total fuel combustion) of East Asia (developing only) and CO2 emissions (% of total fuel combustion) of High income: OECD?
Keep it short and to the point. -13.11. In the year 1980, what is the difference between the CO2 emissions (% of total fuel combustion) of East Asia (developing only) and CO2 emissions (% of total fuel combustion) of Italy?
Your response must be concise. -11.69. In the year 1980, what is the difference between the CO2 emissions (% of total fuel combustion) of East Asia (developing only) and CO2 emissions (% of total fuel combustion) of Philippines?
Provide a short and direct response. -23.2. In the year 1980, what is the difference between the CO2 emissions (% of total fuel combustion) of High income: OECD and CO2 emissions (% of total fuel combustion) of Italy?
Keep it short and to the point. 1.42. In the year 1980, what is the difference between the CO2 emissions (% of total fuel combustion) of High income: OECD and CO2 emissions (% of total fuel combustion) of Philippines?
Provide a short and direct response. -10.09. In the year 1980, what is the difference between the CO2 emissions (% of total fuel combustion) of Italy and CO2 emissions (% of total fuel combustion) of Philippines?
Provide a short and direct response. -11.51. What is the ratio of the CO2 emissions (% of total fuel combustion) in East Asia (developing only) in 1974 to that in 1975?
Offer a terse response. 1.04. What is the ratio of the CO2 emissions (% of total fuel combustion) of High income: OECD in 1974 to that in 1975?
Your response must be concise. 0.95. What is the ratio of the CO2 emissions (% of total fuel combustion) in Italy in 1974 to that in 1975?
Offer a terse response. 0.9. What is the ratio of the CO2 emissions (% of total fuel combustion) of Philippines in 1974 to that in 1975?
Offer a very short reply. 1.06. What is the ratio of the CO2 emissions (% of total fuel combustion) of East Asia (developing only) in 1974 to that in 1976?
Ensure brevity in your answer.  1.06. What is the ratio of the CO2 emissions (% of total fuel combustion) of High income: OECD in 1974 to that in 1976?
Offer a very short reply. 0.96. What is the ratio of the CO2 emissions (% of total fuel combustion) in Italy in 1974 to that in 1976?
Provide a short and direct response. 0.93. What is the ratio of the CO2 emissions (% of total fuel combustion) in Philippines in 1974 to that in 1976?
Your answer should be compact. 1.04. What is the ratio of the CO2 emissions (% of total fuel combustion) of High income: OECD in 1974 to that in 1977?
Offer a very short reply. 0.95. What is the ratio of the CO2 emissions (% of total fuel combustion) in Italy in 1974 to that in 1977?
Your answer should be compact. 0.85. What is the ratio of the CO2 emissions (% of total fuel combustion) of Philippines in 1974 to that in 1977?
Give a very brief answer. 1.13. What is the ratio of the CO2 emissions (% of total fuel combustion) in East Asia (developing only) in 1974 to that in 1978?
Keep it short and to the point. 1.14. What is the ratio of the CO2 emissions (% of total fuel combustion) of High income: OECD in 1974 to that in 1978?
Keep it short and to the point. 0.92. What is the ratio of the CO2 emissions (% of total fuel combustion) of Italy in 1974 to that in 1978?
Your answer should be compact. 0.83. What is the ratio of the CO2 emissions (% of total fuel combustion) in Philippines in 1974 to that in 1978?
Your answer should be compact. 1.13. What is the ratio of the CO2 emissions (% of total fuel combustion) in East Asia (developing only) in 1974 to that in 1979?
Ensure brevity in your answer.  1.12. What is the ratio of the CO2 emissions (% of total fuel combustion) of High income: OECD in 1974 to that in 1979?
Keep it short and to the point. 0.94. What is the ratio of the CO2 emissions (% of total fuel combustion) of Italy in 1974 to that in 1979?
Give a very brief answer. 0.79. What is the ratio of the CO2 emissions (% of total fuel combustion) in Philippines in 1974 to that in 1979?
Keep it short and to the point. 1.17. What is the ratio of the CO2 emissions (% of total fuel combustion) in East Asia (developing only) in 1974 to that in 1980?
Give a very brief answer. 1.12. What is the ratio of the CO2 emissions (% of total fuel combustion) of High income: OECD in 1974 to that in 1980?
Give a very brief answer. 0.93. What is the ratio of the CO2 emissions (% of total fuel combustion) in Italy in 1974 to that in 1980?
Give a very brief answer. 0.78. What is the ratio of the CO2 emissions (% of total fuel combustion) in Philippines in 1974 to that in 1980?
Make the answer very short. 1.14. What is the ratio of the CO2 emissions (% of total fuel combustion) in East Asia (developing only) in 1975 to that in 1976?
Your response must be concise. 1.02. What is the ratio of the CO2 emissions (% of total fuel combustion) of High income: OECD in 1975 to that in 1976?
Keep it short and to the point. 1.01. What is the ratio of the CO2 emissions (% of total fuel combustion) of Italy in 1975 to that in 1976?
Your answer should be compact. 1.04. What is the ratio of the CO2 emissions (% of total fuel combustion) in Philippines in 1975 to that in 1976?
Keep it short and to the point. 0.98. What is the ratio of the CO2 emissions (% of total fuel combustion) in East Asia (developing only) in 1975 to that in 1977?
Ensure brevity in your answer.  1.05. What is the ratio of the CO2 emissions (% of total fuel combustion) in High income: OECD in 1975 to that in 1977?
Provide a short and direct response. 1. What is the ratio of the CO2 emissions (% of total fuel combustion) of Italy in 1975 to that in 1977?
Your answer should be compact. 0.94. What is the ratio of the CO2 emissions (% of total fuel combustion) of Philippines in 1975 to that in 1977?
Give a very brief answer. 1.06. What is the ratio of the CO2 emissions (% of total fuel combustion) in East Asia (developing only) in 1975 to that in 1978?
Your answer should be compact. 1.1. What is the ratio of the CO2 emissions (% of total fuel combustion) of High income: OECD in 1975 to that in 1978?
Keep it short and to the point. 0.97. What is the ratio of the CO2 emissions (% of total fuel combustion) in Italy in 1975 to that in 1978?
Make the answer very short. 0.92. What is the ratio of the CO2 emissions (% of total fuel combustion) of Philippines in 1975 to that in 1978?
Ensure brevity in your answer.  1.07. What is the ratio of the CO2 emissions (% of total fuel combustion) of East Asia (developing only) in 1975 to that in 1979?
Give a very brief answer. 1.07. What is the ratio of the CO2 emissions (% of total fuel combustion) of High income: OECD in 1975 to that in 1979?
Give a very brief answer. 0.99. What is the ratio of the CO2 emissions (% of total fuel combustion) in Italy in 1975 to that in 1979?
Keep it short and to the point. 0.88. What is the ratio of the CO2 emissions (% of total fuel combustion) of Philippines in 1975 to that in 1979?
Your answer should be compact. 1.1. What is the ratio of the CO2 emissions (% of total fuel combustion) in East Asia (developing only) in 1975 to that in 1980?
Your answer should be compact. 1.08. What is the ratio of the CO2 emissions (% of total fuel combustion) in High income: OECD in 1975 to that in 1980?
Ensure brevity in your answer.  0.98. What is the ratio of the CO2 emissions (% of total fuel combustion) of Italy in 1975 to that in 1980?
Provide a short and direct response. 0.87. What is the ratio of the CO2 emissions (% of total fuel combustion) in Philippines in 1975 to that in 1980?
Your answer should be very brief. 1.07. What is the ratio of the CO2 emissions (% of total fuel combustion) of East Asia (developing only) in 1976 to that in 1977?
Give a very brief answer. 1.03. What is the ratio of the CO2 emissions (% of total fuel combustion) in High income: OECD in 1976 to that in 1977?
Give a very brief answer. 0.99. What is the ratio of the CO2 emissions (% of total fuel combustion) in Italy in 1976 to that in 1977?
Ensure brevity in your answer.  0.91. What is the ratio of the CO2 emissions (% of total fuel combustion) of Philippines in 1976 to that in 1977?
Make the answer very short. 1.09. What is the ratio of the CO2 emissions (% of total fuel combustion) in East Asia (developing only) in 1976 to that in 1978?
Provide a short and direct response. 1.08. What is the ratio of the CO2 emissions (% of total fuel combustion) of High income: OECD in 1976 to that in 1978?
Ensure brevity in your answer.  0.96. What is the ratio of the CO2 emissions (% of total fuel combustion) in Italy in 1976 to that in 1978?
Provide a short and direct response. 0.89. What is the ratio of the CO2 emissions (% of total fuel combustion) of Philippines in 1976 to that in 1978?
Your answer should be very brief. 1.09. What is the ratio of the CO2 emissions (% of total fuel combustion) of East Asia (developing only) in 1976 to that in 1979?
Your answer should be compact. 1.05. What is the ratio of the CO2 emissions (% of total fuel combustion) in High income: OECD in 1976 to that in 1979?
Your response must be concise. 0.98. What is the ratio of the CO2 emissions (% of total fuel combustion) in Italy in 1976 to that in 1979?
Offer a terse response. 0.85. What is the ratio of the CO2 emissions (% of total fuel combustion) in Philippines in 1976 to that in 1979?
Give a very brief answer. 1.13. What is the ratio of the CO2 emissions (% of total fuel combustion) of East Asia (developing only) in 1976 to that in 1980?
Your answer should be very brief. 1.06. What is the ratio of the CO2 emissions (% of total fuel combustion) of High income: OECD in 1976 to that in 1980?
Provide a short and direct response. 0.97. What is the ratio of the CO2 emissions (% of total fuel combustion) of Italy in 1976 to that in 1980?
Make the answer very short. 0.84. What is the ratio of the CO2 emissions (% of total fuel combustion) of Philippines in 1976 to that in 1980?
Give a very brief answer. 1.1. What is the ratio of the CO2 emissions (% of total fuel combustion) of East Asia (developing only) in 1977 to that in 1978?
Provide a succinct answer. 1.04. What is the ratio of the CO2 emissions (% of total fuel combustion) of High income: OECD in 1977 to that in 1978?
Your answer should be compact. 0.97. What is the ratio of the CO2 emissions (% of total fuel combustion) of Italy in 1977 to that in 1978?
Keep it short and to the point. 0.98. What is the ratio of the CO2 emissions (% of total fuel combustion) in Philippines in 1977 to that in 1978?
Provide a short and direct response. 1.01. What is the ratio of the CO2 emissions (% of total fuel combustion) of East Asia (developing only) in 1977 to that in 1979?
Your answer should be very brief. 1.02. What is the ratio of the CO2 emissions (% of total fuel combustion) of Italy in 1977 to that in 1979?
Your response must be concise. 0.93. What is the ratio of the CO2 emissions (% of total fuel combustion) of Philippines in 1977 to that in 1979?
Provide a succinct answer. 1.04. What is the ratio of the CO2 emissions (% of total fuel combustion) of East Asia (developing only) in 1977 to that in 1980?
Your answer should be compact. 1.02. What is the ratio of the CO2 emissions (% of total fuel combustion) in Italy in 1977 to that in 1980?
Offer a very short reply. 0.92. What is the ratio of the CO2 emissions (% of total fuel combustion) in Philippines in 1977 to that in 1980?
Your answer should be compact. 1.01. What is the ratio of the CO2 emissions (% of total fuel combustion) in East Asia (developing only) in 1978 to that in 1979?
Make the answer very short. 0.98. What is the ratio of the CO2 emissions (% of total fuel combustion) in High income: OECD in 1978 to that in 1979?
Provide a succinct answer. 1.02. What is the ratio of the CO2 emissions (% of total fuel combustion) of Italy in 1978 to that in 1979?
Give a very brief answer. 0.95. What is the ratio of the CO2 emissions (% of total fuel combustion) of Philippines in 1978 to that in 1979?
Offer a very short reply. 1.03. What is the ratio of the CO2 emissions (% of total fuel combustion) in East Asia (developing only) in 1978 to that in 1980?
Keep it short and to the point. 0.98. What is the ratio of the CO2 emissions (% of total fuel combustion) in High income: OECD in 1978 to that in 1980?
Provide a succinct answer. 1.01. What is the ratio of the CO2 emissions (% of total fuel combustion) of Italy in 1978 to that in 1980?
Your answer should be very brief. 0.94. What is the ratio of the CO2 emissions (% of total fuel combustion) of Philippines in 1978 to that in 1980?
Provide a succinct answer. 1.01. What is the ratio of the CO2 emissions (% of total fuel combustion) in East Asia (developing only) in 1979 to that in 1980?
Make the answer very short. 1. What is the ratio of the CO2 emissions (% of total fuel combustion) in Italy in 1979 to that in 1980?
Your answer should be compact. 0.99. What is the ratio of the CO2 emissions (% of total fuel combustion) in Philippines in 1979 to that in 1980?
Your answer should be very brief. 0.97. What is the difference between the highest and the second highest CO2 emissions (% of total fuel combustion) of East Asia (developing only)?
Provide a short and direct response. 0.37. What is the difference between the highest and the second highest CO2 emissions (% of total fuel combustion) in High income: OECD?
Keep it short and to the point. 0.2. What is the difference between the highest and the second highest CO2 emissions (% of total fuel combustion) in Italy?
Provide a short and direct response. 0.2. What is the difference between the highest and the second highest CO2 emissions (% of total fuel combustion) in Philippines?
Your answer should be compact. 1.28. What is the difference between the highest and the lowest CO2 emissions (% of total fuel combustion) in High income: OECD?
Offer a very short reply. 1.69. What is the difference between the highest and the lowest CO2 emissions (% of total fuel combustion) of Italy?
Your answer should be compact. 4.27. What is the difference between the highest and the lowest CO2 emissions (% of total fuel combustion) of Philippines?
Your answer should be compact. 5.15. 